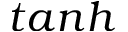Convert formula to latex. <formula><loc_0><loc_0><loc_500><loc_500>t a n h</formula> 